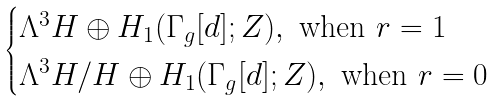Convert formula to latex. <formula><loc_0><loc_0><loc_500><loc_500>\begin{cases} \Lambda ^ { 3 } H \oplus H _ { 1 } ( \Gamma _ { g } [ d ] ; Z ) , \text { when } r = 1 \\ \Lambda ^ { 3 } H / H \oplus H _ { 1 } ( \Gamma _ { g } [ d ] ; Z ) , \text { when } r = 0 \end{cases}</formula> 